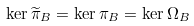<formula> <loc_0><loc_0><loc_500><loc_500>\ker \widetilde { \pi } _ { B } = \ker \pi _ { B } = \ker \Omega _ { B }</formula> 